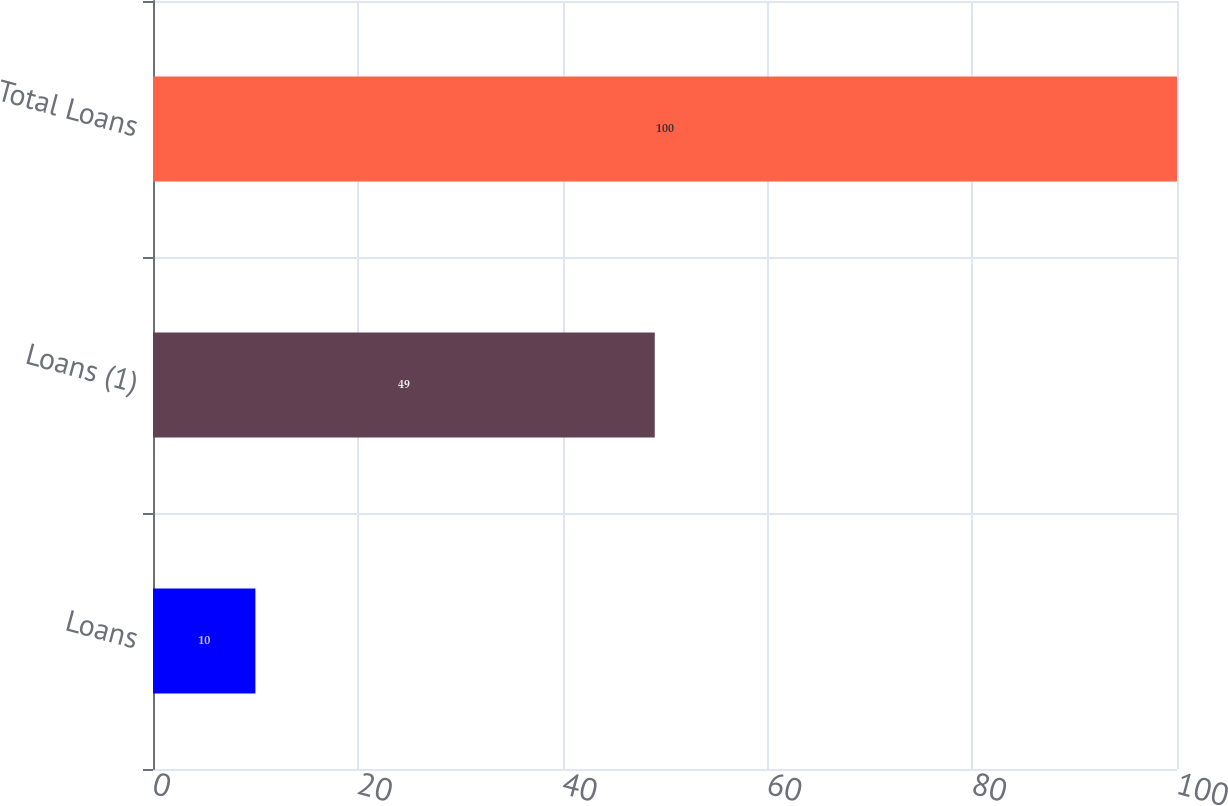Convert chart to OTSL. <chart><loc_0><loc_0><loc_500><loc_500><bar_chart><fcel>Loans<fcel>Loans (1)<fcel>Total Loans<nl><fcel>10<fcel>49<fcel>100<nl></chart> 